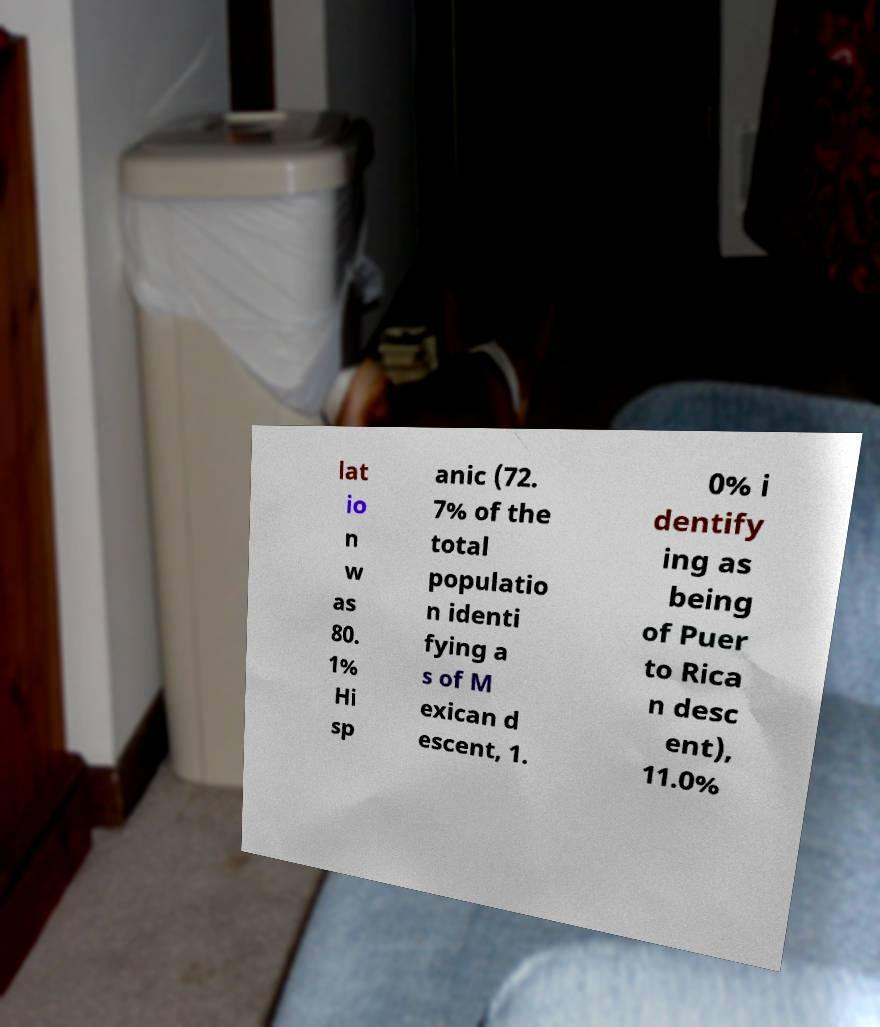Please identify and transcribe the text found in this image. lat io n w as 80. 1% Hi sp anic (72. 7% of the total populatio n identi fying a s of M exican d escent, 1. 0% i dentify ing as being of Puer to Rica n desc ent), 11.0% 